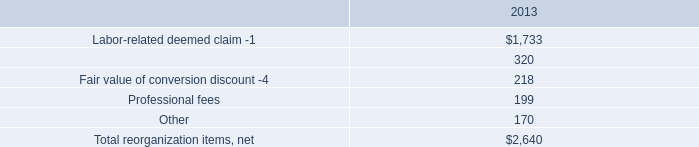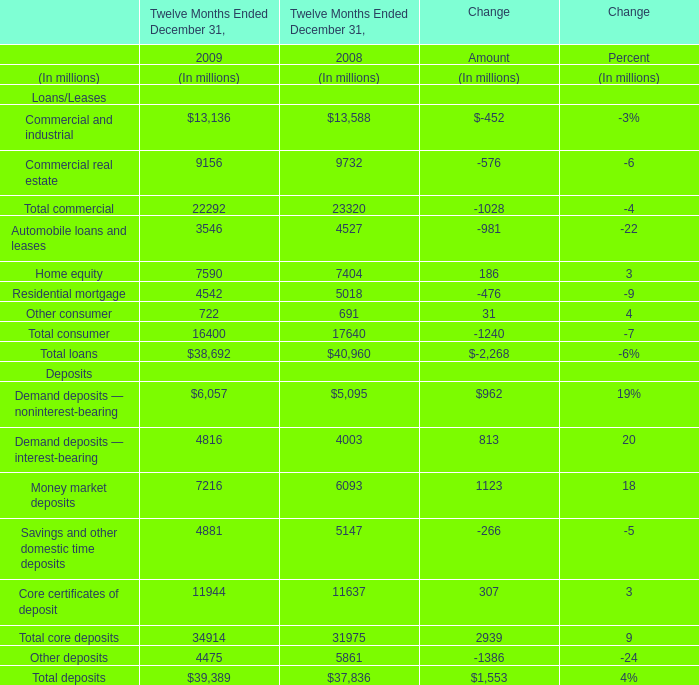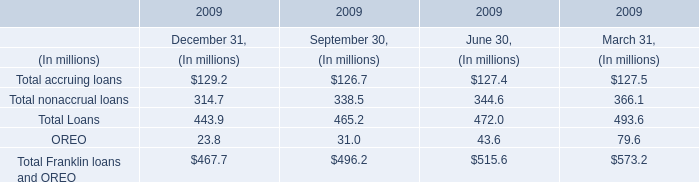what was the ratio of the 2014 non operating expense related to early debt extinguishment charges to 2013 
Computations: (48 / 29)
Answer: 1.65517. 